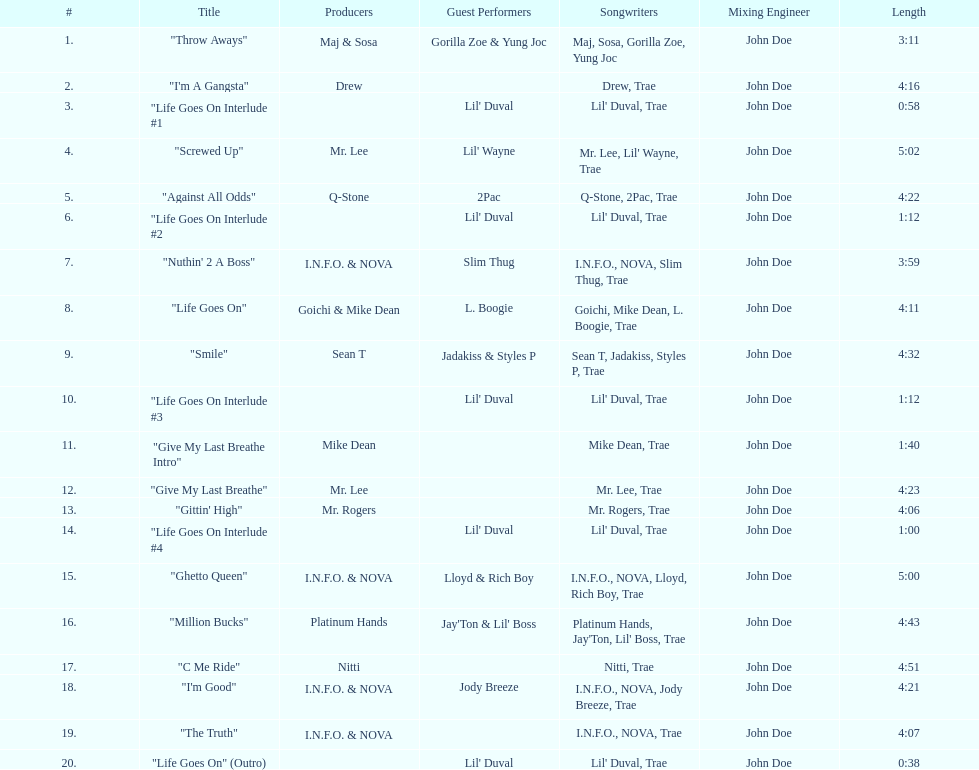How long is track number 11? 1:40. Parse the table in full. {'header': ['#', 'Title', 'Producers', 'Guest Performers', 'Songwriters', 'Mixing Engineer', 'Length'], 'rows': [['1.', '"Throw Aways"', 'Maj & Sosa', 'Gorilla Zoe & Yung Joc', 'Maj, Sosa, Gorilla Zoe, Yung Joc', 'John Doe', '3:11'], ['2.', '"I\'m A Gangsta"', 'Drew', '', 'Drew, Trae', 'John Doe', '4:16'], ['3.', '"Life Goes On Interlude #1', '', "Lil' Duval", "Lil' Duval, Trae", 'John Doe', '0:58'], ['4.', '"Screwed Up"', 'Mr. Lee', "Lil' Wayne", "Mr. Lee, Lil' Wayne, Trae", 'John Doe', '5:02'], ['5.', '"Against All Odds"', 'Q-Stone', '2Pac', 'Q-Stone, 2Pac, Trae', 'John Doe', '4:22'], ['6.', '"Life Goes On Interlude #2', '', "Lil' Duval", "Lil' Duval, Trae", 'John Doe', '1:12'], ['7.', '"Nuthin\' 2 A Boss"', 'I.N.F.O. & NOVA', 'Slim Thug', 'I.N.F.O., NOVA, Slim Thug, Trae', 'John Doe', '3:59'], ['8.', '"Life Goes On"', 'Goichi & Mike Dean', 'L. Boogie', 'Goichi, Mike Dean, L. Boogie, Trae', 'John Doe', '4:11'], ['9.', '"Smile"', 'Sean T', 'Jadakiss & Styles P', 'Sean T, Jadakiss, Styles P, Trae', 'John Doe', '4:32'], ['10.', '"Life Goes On Interlude #3', '', "Lil' Duval", "Lil' Duval, Trae", 'John Doe', '1:12'], ['11.', '"Give My Last Breathe Intro"', 'Mike Dean', '', 'Mike Dean, Trae', 'John Doe', '1:40'], ['12.', '"Give My Last Breathe"', 'Mr. Lee', '', 'Mr. Lee, Trae', 'John Doe', '4:23'], ['13.', '"Gittin\' High"', 'Mr. Rogers', '', 'Mr. Rogers, Trae', 'John Doe', '4:06'], ['14.', '"Life Goes On Interlude #4', '', "Lil' Duval", "Lil' Duval, Trae", 'John Doe', '1:00'], ['15.', '"Ghetto Queen"', 'I.N.F.O. & NOVA', 'Lloyd & Rich Boy', 'I.N.F.O., NOVA, Lloyd, Rich Boy, Trae', 'John Doe', '5:00'], ['16.', '"Million Bucks"', 'Platinum Hands', "Jay'Ton & Lil' Boss", "Platinum Hands, Jay'Ton, Lil' Boss, Trae", 'John Doe', '4:43'], ['17.', '"C Me Ride"', 'Nitti', '', 'Nitti, Trae', 'John Doe', '4:51'], ['18.', '"I\'m Good"', 'I.N.F.O. & NOVA', 'Jody Breeze', 'I.N.F.O., NOVA, Jody Breeze, Trae', 'John Doe', '4:21'], ['19.', '"The Truth"', 'I.N.F.O. & NOVA', '', 'I.N.F.O., NOVA, Trae', 'John Doe', '4:07'], ['20.', '"Life Goes On" (Outro)', '', "Lil' Duval", "Lil' Duval, Trae", 'John Doe', '0:38']]} 